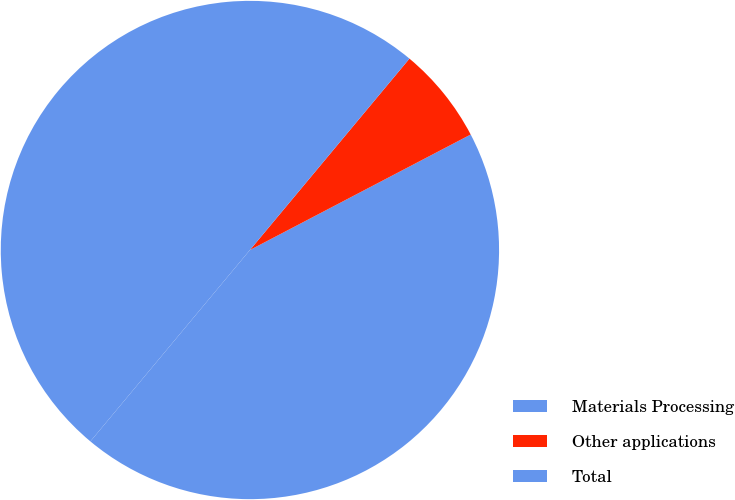Convert chart. <chart><loc_0><loc_0><loc_500><loc_500><pie_chart><fcel>Materials Processing<fcel>Other applications<fcel>Total<nl><fcel>43.73%<fcel>6.27%<fcel>50.0%<nl></chart> 